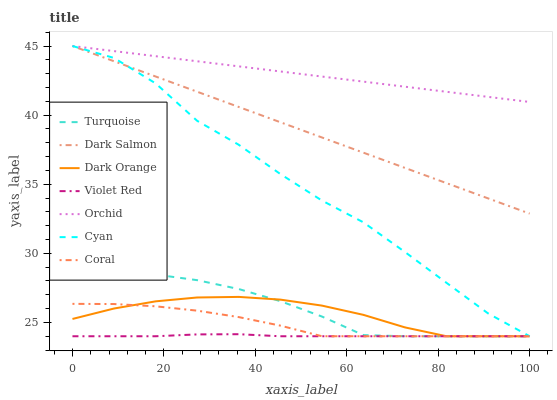Does Turquoise have the minimum area under the curve?
Answer yes or no. No. Does Turquoise have the maximum area under the curve?
Answer yes or no. No. Is Turquoise the smoothest?
Answer yes or no. No. Is Turquoise the roughest?
Answer yes or no. No. Does Dark Salmon have the lowest value?
Answer yes or no. No. Does Turquoise have the highest value?
Answer yes or no. No. Is Coral less than Dark Salmon?
Answer yes or no. Yes. Is Dark Salmon greater than Coral?
Answer yes or no. Yes. Does Coral intersect Dark Salmon?
Answer yes or no. No. 